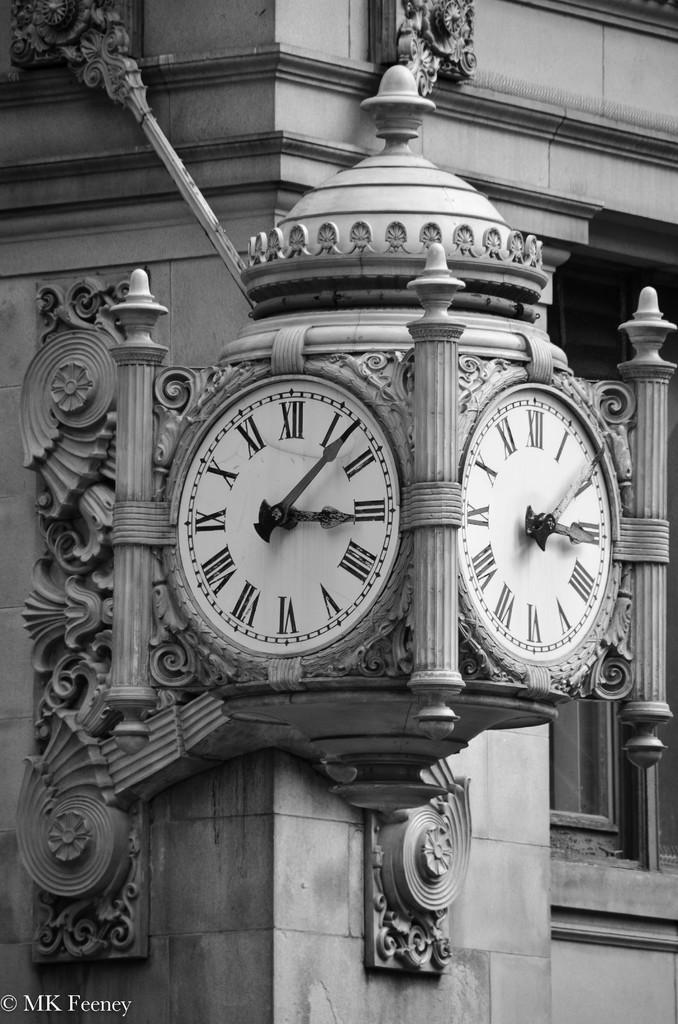<image>
Share a concise interpretation of the image provided. A photograph by MK Feeney shows a black and white clock tower. 